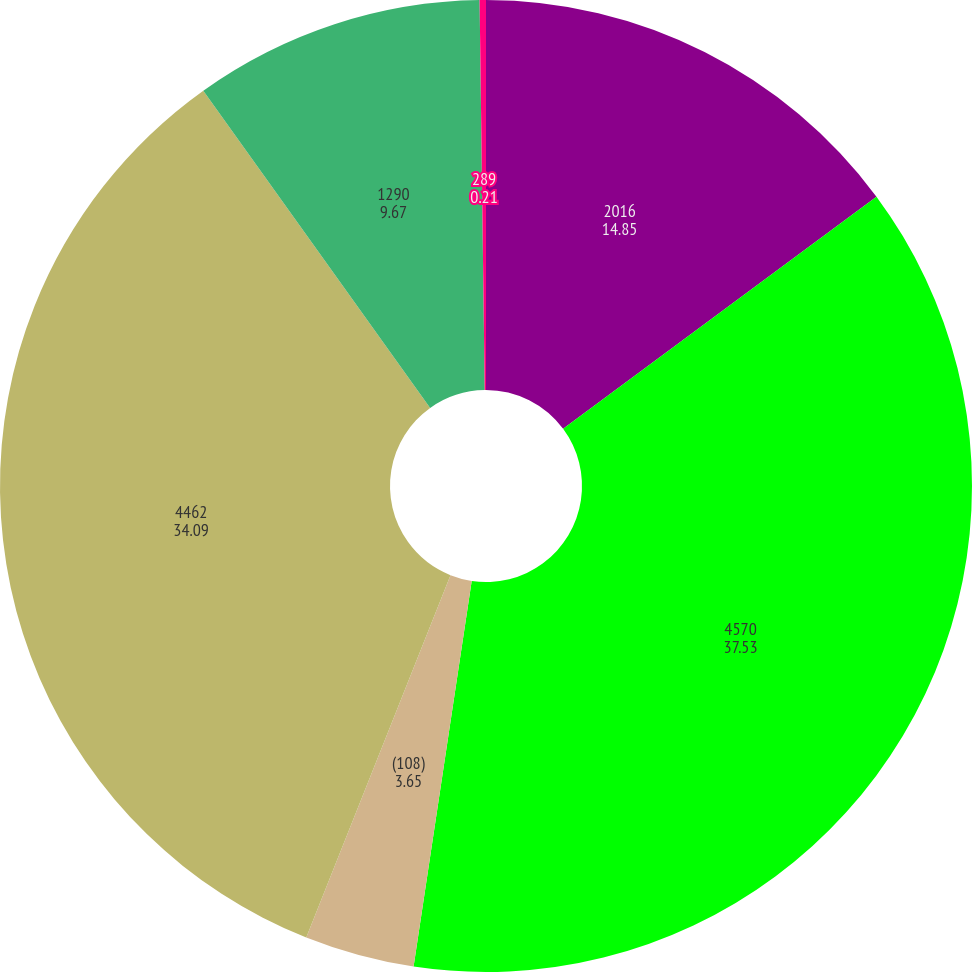Convert chart. <chart><loc_0><loc_0><loc_500><loc_500><pie_chart><fcel>2016<fcel>4570<fcel>(108)<fcel>4462<fcel>1290<fcel>289<nl><fcel>14.85%<fcel>37.53%<fcel>3.65%<fcel>34.09%<fcel>9.67%<fcel>0.21%<nl></chart> 